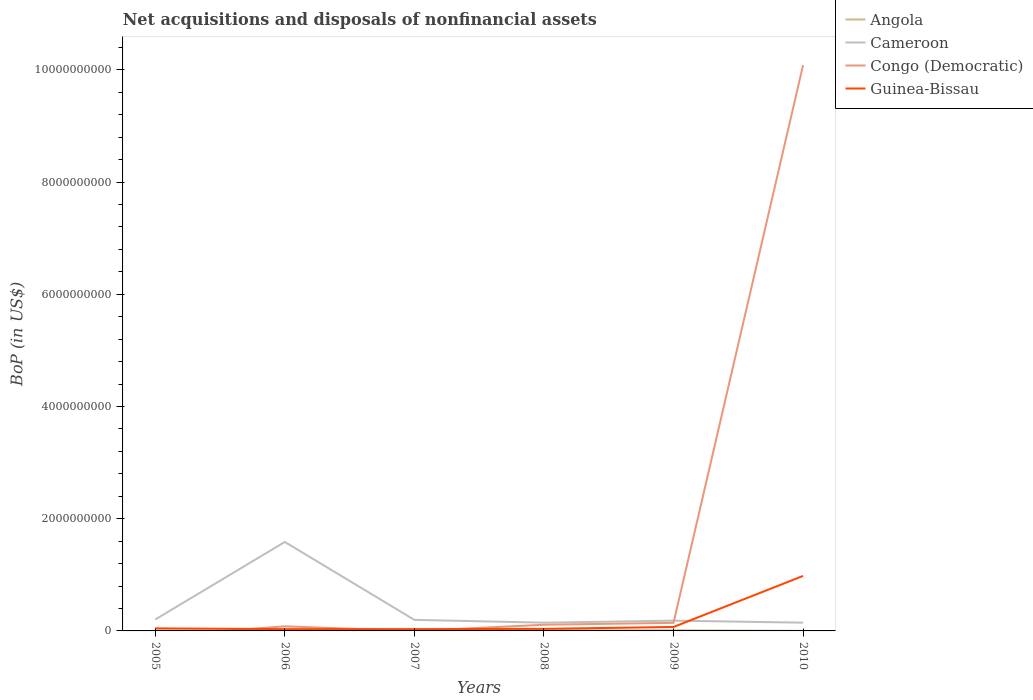How many different coloured lines are there?
Your response must be concise. 4. Does the line corresponding to Angola intersect with the line corresponding to Cameroon?
Offer a very short reply. No. Is the number of lines equal to the number of legend labels?
Your answer should be compact. No. Across all years, what is the maximum Balance of Payments in Guinea-Bissau?
Make the answer very short. 3.21e+07. What is the total Balance of Payments in Congo (Democratic) in the graph?
Offer a very short reply. -2.84e+07. What is the difference between the highest and the second highest Balance of Payments in Angola?
Your answer should be compact. 1.20e+07. What is the difference between the highest and the lowest Balance of Payments in Cameroon?
Make the answer very short. 1. How many lines are there?
Offer a terse response. 4. What is the difference between two consecutive major ticks on the Y-axis?
Offer a terse response. 2.00e+09. Are the values on the major ticks of Y-axis written in scientific E-notation?
Provide a short and direct response. No. Does the graph contain any zero values?
Your answer should be very brief. Yes. Does the graph contain grids?
Your answer should be compact. No. How are the legend labels stacked?
Ensure brevity in your answer.  Vertical. What is the title of the graph?
Keep it short and to the point. Net acquisitions and disposals of nonfinancial assets. What is the label or title of the Y-axis?
Make the answer very short. BoP (in US$). What is the BoP (in US$) of Angola in 2005?
Make the answer very short. 7.77e+06. What is the BoP (in US$) of Cameroon in 2005?
Provide a short and direct response. 2.04e+08. What is the BoP (in US$) in Congo (Democratic) in 2005?
Offer a terse response. 0. What is the BoP (in US$) in Guinea-Bissau in 2005?
Offer a very short reply. 4.54e+07. What is the BoP (in US$) of Angola in 2006?
Keep it short and to the point. 1.44e+06. What is the BoP (in US$) in Cameroon in 2006?
Offer a terse response. 1.59e+09. What is the BoP (in US$) of Congo (Democratic) in 2006?
Your response must be concise. 8.17e+07. What is the BoP (in US$) of Guinea-Bissau in 2006?
Provide a short and direct response. 3.22e+07. What is the BoP (in US$) of Angola in 2007?
Provide a succinct answer. 7.17e+06. What is the BoP (in US$) of Cameroon in 2007?
Your answer should be very brief. 1.97e+08. What is the BoP (in US$) of Congo (Democratic) in 2007?
Your answer should be compact. 0. What is the BoP (in US$) in Guinea-Bissau in 2007?
Your response must be concise. 3.21e+07. What is the BoP (in US$) in Angola in 2008?
Provide a succinct answer. 1.29e+07. What is the BoP (in US$) of Cameroon in 2008?
Provide a succinct answer. 1.47e+08. What is the BoP (in US$) in Congo (Democratic) in 2008?
Your answer should be compact. 1.10e+08. What is the BoP (in US$) in Guinea-Bissau in 2008?
Your answer should be compact. 3.68e+07. What is the BoP (in US$) of Angola in 2009?
Your response must be concise. 1.13e+07. What is the BoP (in US$) in Cameroon in 2009?
Give a very brief answer. 1.84e+08. What is the BoP (in US$) of Congo (Democratic) in 2009?
Offer a very short reply. 1.44e+08. What is the BoP (in US$) of Guinea-Bissau in 2009?
Your answer should be very brief. 7.05e+07. What is the BoP (in US$) in Angola in 2010?
Provide a succinct answer. 9.34e+05. What is the BoP (in US$) in Cameroon in 2010?
Keep it short and to the point. 1.47e+08. What is the BoP (in US$) in Congo (Democratic) in 2010?
Ensure brevity in your answer.  1.01e+1. What is the BoP (in US$) of Guinea-Bissau in 2010?
Make the answer very short. 9.80e+08. Across all years, what is the maximum BoP (in US$) in Angola?
Make the answer very short. 1.29e+07. Across all years, what is the maximum BoP (in US$) in Cameroon?
Provide a short and direct response. 1.59e+09. Across all years, what is the maximum BoP (in US$) in Congo (Democratic)?
Make the answer very short. 1.01e+1. Across all years, what is the maximum BoP (in US$) in Guinea-Bissau?
Offer a very short reply. 9.80e+08. Across all years, what is the minimum BoP (in US$) of Angola?
Keep it short and to the point. 9.34e+05. Across all years, what is the minimum BoP (in US$) of Cameroon?
Give a very brief answer. 1.47e+08. Across all years, what is the minimum BoP (in US$) in Guinea-Bissau?
Your answer should be very brief. 3.21e+07. What is the total BoP (in US$) of Angola in the graph?
Keep it short and to the point. 4.15e+07. What is the total BoP (in US$) in Cameroon in the graph?
Provide a short and direct response. 2.46e+09. What is the total BoP (in US$) of Congo (Democratic) in the graph?
Your response must be concise. 1.04e+1. What is the total BoP (in US$) of Guinea-Bissau in the graph?
Offer a very short reply. 1.20e+09. What is the difference between the BoP (in US$) in Angola in 2005 and that in 2006?
Provide a succinct answer. 6.33e+06. What is the difference between the BoP (in US$) of Cameroon in 2005 and that in 2006?
Keep it short and to the point. -1.38e+09. What is the difference between the BoP (in US$) in Guinea-Bissau in 2005 and that in 2006?
Give a very brief answer. 1.32e+07. What is the difference between the BoP (in US$) in Angola in 2005 and that in 2007?
Keep it short and to the point. 5.95e+05. What is the difference between the BoP (in US$) in Cameroon in 2005 and that in 2007?
Ensure brevity in your answer.  6.52e+06. What is the difference between the BoP (in US$) of Guinea-Bissau in 2005 and that in 2007?
Provide a succinct answer. 1.33e+07. What is the difference between the BoP (in US$) in Angola in 2005 and that in 2008?
Your answer should be very brief. -5.13e+06. What is the difference between the BoP (in US$) of Cameroon in 2005 and that in 2008?
Offer a very short reply. 5.68e+07. What is the difference between the BoP (in US$) in Guinea-Bissau in 2005 and that in 2008?
Offer a very short reply. 8.62e+06. What is the difference between the BoP (in US$) in Angola in 2005 and that in 2009?
Make the answer very short. -3.49e+06. What is the difference between the BoP (in US$) of Cameroon in 2005 and that in 2009?
Make the answer very short. 2.02e+07. What is the difference between the BoP (in US$) of Guinea-Bissau in 2005 and that in 2009?
Keep it short and to the point. -2.51e+07. What is the difference between the BoP (in US$) in Angola in 2005 and that in 2010?
Ensure brevity in your answer.  6.84e+06. What is the difference between the BoP (in US$) of Cameroon in 2005 and that in 2010?
Give a very brief answer. 5.67e+07. What is the difference between the BoP (in US$) in Guinea-Bissau in 2005 and that in 2010?
Your response must be concise. -9.35e+08. What is the difference between the BoP (in US$) of Angola in 2006 and that in 2007?
Offer a terse response. -5.73e+06. What is the difference between the BoP (in US$) of Cameroon in 2006 and that in 2007?
Make the answer very short. 1.39e+09. What is the difference between the BoP (in US$) in Guinea-Bissau in 2006 and that in 2007?
Make the answer very short. 7.78e+04. What is the difference between the BoP (in US$) in Angola in 2006 and that in 2008?
Your response must be concise. -1.15e+07. What is the difference between the BoP (in US$) of Cameroon in 2006 and that in 2008?
Ensure brevity in your answer.  1.44e+09. What is the difference between the BoP (in US$) of Congo (Democratic) in 2006 and that in 2008?
Ensure brevity in your answer.  -2.84e+07. What is the difference between the BoP (in US$) in Guinea-Bissau in 2006 and that in 2008?
Ensure brevity in your answer.  -4.58e+06. What is the difference between the BoP (in US$) of Angola in 2006 and that in 2009?
Give a very brief answer. -9.82e+06. What is the difference between the BoP (in US$) in Cameroon in 2006 and that in 2009?
Your answer should be compact. 1.40e+09. What is the difference between the BoP (in US$) in Congo (Democratic) in 2006 and that in 2009?
Your response must be concise. -6.22e+07. What is the difference between the BoP (in US$) in Guinea-Bissau in 2006 and that in 2009?
Your response must be concise. -3.83e+07. What is the difference between the BoP (in US$) in Angola in 2006 and that in 2010?
Your response must be concise. 5.06e+05. What is the difference between the BoP (in US$) of Cameroon in 2006 and that in 2010?
Provide a succinct answer. 1.44e+09. What is the difference between the BoP (in US$) of Congo (Democratic) in 2006 and that in 2010?
Offer a very short reply. -1.00e+1. What is the difference between the BoP (in US$) of Guinea-Bissau in 2006 and that in 2010?
Ensure brevity in your answer.  -9.48e+08. What is the difference between the BoP (in US$) of Angola in 2007 and that in 2008?
Provide a short and direct response. -5.72e+06. What is the difference between the BoP (in US$) of Cameroon in 2007 and that in 2008?
Your response must be concise. 5.03e+07. What is the difference between the BoP (in US$) in Guinea-Bissau in 2007 and that in 2008?
Give a very brief answer. -4.66e+06. What is the difference between the BoP (in US$) of Angola in 2007 and that in 2009?
Your answer should be compact. -4.08e+06. What is the difference between the BoP (in US$) in Cameroon in 2007 and that in 2009?
Keep it short and to the point. 1.36e+07. What is the difference between the BoP (in US$) in Guinea-Bissau in 2007 and that in 2009?
Offer a very short reply. -3.83e+07. What is the difference between the BoP (in US$) in Angola in 2007 and that in 2010?
Ensure brevity in your answer.  6.24e+06. What is the difference between the BoP (in US$) of Cameroon in 2007 and that in 2010?
Provide a succinct answer. 5.02e+07. What is the difference between the BoP (in US$) in Guinea-Bissau in 2007 and that in 2010?
Offer a terse response. -9.48e+08. What is the difference between the BoP (in US$) of Angola in 2008 and that in 2009?
Your answer should be compact. 1.64e+06. What is the difference between the BoP (in US$) in Cameroon in 2008 and that in 2009?
Ensure brevity in your answer.  -3.67e+07. What is the difference between the BoP (in US$) of Congo (Democratic) in 2008 and that in 2009?
Make the answer very short. -3.39e+07. What is the difference between the BoP (in US$) in Guinea-Bissau in 2008 and that in 2009?
Your response must be concise. -3.37e+07. What is the difference between the BoP (in US$) in Angola in 2008 and that in 2010?
Offer a very short reply. 1.20e+07. What is the difference between the BoP (in US$) in Cameroon in 2008 and that in 2010?
Ensure brevity in your answer.  -1.03e+05. What is the difference between the BoP (in US$) of Congo (Democratic) in 2008 and that in 2010?
Provide a short and direct response. -9.97e+09. What is the difference between the BoP (in US$) of Guinea-Bissau in 2008 and that in 2010?
Provide a short and direct response. -9.44e+08. What is the difference between the BoP (in US$) of Angola in 2009 and that in 2010?
Your answer should be very brief. 1.03e+07. What is the difference between the BoP (in US$) in Cameroon in 2009 and that in 2010?
Offer a very short reply. 3.65e+07. What is the difference between the BoP (in US$) in Congo (Democratic) in 2009 and that in 2010?
Offer a terse response. -9.94e+09. What is the difference between the BoP (in US$) in Guinea-Bissau in 2009 and that in 2010?
Make the answer very short. -9.10e+08. What is the difference between the BoP (in US$) of Angola in 2005 and the BoP (in US$) of Cameroon in 2006?
Your answer should be very brief. -1.58e+09. What is the difference between the BoP (in US$) of Angola in 2005 and the BoP (in US$) of Congo (Democratic) in 2006?
Your response must be concise. -7.40e+07. What is the difference between the BoP (in US$) of Angola in 2005 and the BoP (in US$) of Guinea-Bissau in 2006?
Ensure brevity in your answer.  -2.44e+07. What is the difference between the BoP (in US$) in Cameroon in 2005 and the BoP (in US$) in Congo (Democratic) in 2006?
Provide a short and direct response. 1.22e+08. What is the difference between the BoP (in US$) in Cameroon in 2005 and the BoP (in US$) in Guinea-Bissau in 2006?
Offer a very short reply. 1.71e+08. What is the difference between the BoP (in US$) in Angola in 2005 and the BoP (in US$) in Cameroon in 2007?
Provide a short and direct response. -1.89e+08. What is the difference between the BoP (in US$) in Angola in 2005 and the BoP (in US$) in Guinea-Bissau in 2007?
Keep it short and to the point. -2.44e+07. What is the difference between the BoP (in US$) in Cameroon in 2005 and the BoP (in US$) in Guinea-Bissau in 2007?
Keep it short and to the point. 1.72e+08. What is the difference between the BoP (in US$) of Angola in 2005 and the BoP (in US$) of Cameroon in 2008?
Give a very brief answer. -1.39e+08. What is the difference between the BoP (in US$) of Angola in 2005 and the BoP (in US$) of Congo (Democratic) in 2008?
Keep it short and to the point. -1.02e+08. What is the difference between the BoP (in US$) in Angola in 2005 and the BoP (in US$) in Guinea-Bissau in 2008?
Ensure brevity in your answer.  -2.90e+07. What is the difference between the BoP (in US$) of Cameroon in 2005 and the BoP (in US$) of Congo (Democratic) in 2008?
Your answer should be very brief. 9.36e+07. What is the difference between the BoP (in US$) of Cameroon in 2005 and the BoP (in US$) of Guinea-Bissau in 2008?
Provide a succinct answer. 1.67e+08. What is the difference between the BoP (in US$) of Angola in 2005 and the BoP (in US$) of Cameroon in 2009?
Your response must be concise. -1.76e+08. What is the difference between the BoP (in US$) of Angola in 2005 and the BoP (in US$) of Congo (Democratic) in 2009?
Give a very brief answer. -1.36e+08. What is the difference between the BoP (in US$) in Angola in 2005 and the BoP (in US$) in Guinea-Bissau in 2009?
Provide a succinct answer. -6.27e+07. What is the difference between the BoP (in US$) of Cameroon in 2005 and the BoP (in US$) of Congo (Democratic) in 2009?
Your answer should be compact. 5.97e+07. What is the difference between the BoP (in US$) of Cameroon in 2005 and the BoP (in US$) of Guinea-Bissau in 2009?
Offer a very short reply. 1.33e+08. What is the difference between the BoP (in US$) in Angola in 2005 and the BoP (in US$) in Cameroon in 2010?
Provide a short and direct response. -1.39e+08. What is the difference between the BoP (in US$) of Angola in 2005 and the BoP (in US$) of Congo (Democratic) in 2010?
Offer a terse response. -1.01e+1. What is the difference between the BoP (in US$) of Angola in 2005 and the BoP (in US$) of Guinea-Bissau in 2010?
Keep it short and to the point. -9.73e+08. What is the difference between the BoP (in US$) in Cameroon in 2005 and the BoP (in US$) in Congo (Democratic) in 2010?
Offer a very short reply. -9.88e+09. What is the difference between the BoP (in US$) in Cameroon in 2005 and the BoP (in US$) in Guinea-Bissau in 2010?
Offer a very short reply. -7.77e+08. What is the difference between the BoP (in US$) of Angola in 2006 and the BoP (in US$) of Cameroon in 2007?
Your answer should be very brief. -1.96e+08. What is the difference between the BoP (in US$) in Angola in 2006 and the BoP (in US$) in Guinea-Bissau in 2007?
Keep it short and to the point. -3.07e+07. What is the difference between the BoP (in US$) of Cameroon in 2006 and the BoP (in US$) of Guinea-Bissau in 2007?
Your answer should be very brief. 1.55e+09. What is the difference between the BoP (in US$) of Congo (Democratic) in 2006 and the BoP (in US$) of Guinea-Bissau in 2007?
Offer a very short reply. 4.96e+07. What is the difference between the BoP (in US$) in Angola in 2006 and the BoP (in US$) in Cameroon in 2008?
Make the answer very short. -1.45e+08. What is the difference between the BoP (in US$) in Angola in 2006 and the BoP (in US$) in Congo (Democratic) in 2008?
Make the answer very short. -1.09e+08. What is the difference between the BoP (in US$) of Angola in 2006 and the BoP (in US$) of Guinea-Bissau in 2008?
Provide a succinct answer. -3.53e+07. What is the difference between the BoP (in US$) in Cameroon in 2006 and the BoP (in US$) in Congo (Democratic) in 2008?
Provide a short and direct response. 1.48e+09. What is the difference between the BoP (in US$) of Cameroon in 2006 and the BoP (in US$) of Guinea-Bissau in 2008?
Offer a very short reply. 1.55e+09. What is the difference between the BoP (in US$) of Congo (Democratic) in 2006 and the BoP (in US$) of Guinea-Bissau in 2008?
Make the answer very short. 4.49e+07. What is the difference between the BoP (in US$) in Angola in 2006 and the BoP (in US$) in Cameroon in 2009?
Provide a short and direct response. -1.82e+08. What is the difference between the BoP (in US$) in Angola in 2006 and the BoP (in US$) in Congo (Democratic) in 2009?
Provide a short and direct response. -1.43e+08. What is the difference between the BoP (in US$) of Angola in 2006 and the BoP (in US$) of Guinea-Bissau in 2009?
Give a very brief answer. -6.90e+07. What is the difference between the BoP (in US$) in Cameroon in 2006 and the BoP (in US$) in Congo (Democratic) in 2009?
Offer a terse response. 1.44e+09. What is the difference between the BoP (in US$) in Cameroon in 2006 and the BoP (in US$) in Guinea-Bissau in 2009?
Your answer should be compact. 1.52e+09. What is the difference between the BoP (in US$) in Congo (Democratic) in 2006 and the BoP (in US$) in Guinea-Bissau in 2009?
Give a very brief answer. 1.13e+07. What is the difference between the BoP (in US$) in Angola in 2006 and the BoP (in US$) in Cameroon in 2010?
Offer a terse response. -1.46e+08. What is the difference between the BoP (in US$) in Angola in 2006 and the BoP (in US$) in Congo (Democratic) in 2010?
Offer a terse response. -1.01e+1. What is the difference between the BoP (in US$) in Angola in 2006 and the BoP (in US$) in Guinea-Bissau in 2010?
Give a very brief answer. -9.79e+08. What is the difference between the BoP (in US$) of Cameroon in 2006 and the BoP (in US$) of Congo (Democratic) in 2010?
Offer a very short reply. -8.50e+09. What is the difference between the BoP (in US$) in Cameroon in 2006 and the BoP (in US$) in Guinea-Bissau in 2010?
Your answer should be very brief. 6.05e+08. What is the difference between the BoP (in US$) in Congo (Democratic) in 2006 and the BoP (in US$) in Guinea-Bissau in 2010?
Make the answer very short. -8.99e+08. What is the difference between the BoP (in US$) in Angola in 2007 and the BoP (in US$) in Cameroon in 2008?
Make the answer very short. -1.40e+08. What is the difference between the BoP (in US$) of Angola in 2007 and the BoP (in US$) of Congo (Democratic) in 2008?
Your response must be concise. -1.03e+08. What is the difference between the BoP (in US$) of Angola in 2007 and the BoP (in US$) of Guinea-Bissau in 2008?
Keep it short and to the point. -2.96e+07. What is the difference between the BoP (in US$) of Cameroon in 2007 and the BoP (in US$) of Congo (Democratic) in 2008?
Your answer should be compact. 8.71e+07. What is the difference between the BoP (in US$) of Cameroon in 2007 and the BoP (in US$) of Guinea-Bissau in 2008?
Your response must be concise. 1.60e+08. What is the difference between the BoP (in US$) of Angola in 2007 and the BoP (in US$) of Cameroon in 2009?
Ensure brevity in your answer.  -1.76e+08. What is the difference between the BoP (in US$) in Angola in 2007 and the BoP (in US$) in Congo (Democratic) in 2009?
Provide a succinct answer. -1.37e+08. What is the difference between the BoP (in US$) in Angola in 2007 and the BoP (in US$) in Guinea-Bissau in 2009?
Offer a very short reply. -6.33e+07. What is the difference between the BoP (in US$) in Cameroon in 2007 and the BoP (in US$) in Congo (Democratic) in 2009?
Provide a succinct answer. 5.32e+07. What is the difference between the BoP (in US$) of Cameroon in 2007 and the BoP (in US$) of Guinea-Bissau in 2009?
Provide a short and direct response. 1.27e+08. What is the difference between the BoP (in US$) in Angola in 2007 and the BoP (in US$) in Cameroon in 2010?
Offer a terse response. -1.40e+08. What is the difference between the BoP (in US$) in Angola in 2007 and the BoP (in US$) in Congo (Democratic) in 2010?
Give a very brief answer. -1.01e+1. What is the difference between the BoP (in US$) in Angola in 2007 and the BoP (in US$) in Guinea-Bissau in 2010?
Offer a terse response. -9.73e+08. What is the difference between the BoP (in US$) of Cameroon in 2007 and the BoP (in US$) of Congo (Democratic) in 2010?
Your response must be concise. -9.89e+09. What is the difference between the BoP (in US$) in Cameroon in 2007 and the BoP (in US$) in Guinea-Bissau in 2010?
Your answer should be compact. -7.83e+08. What is the difference between the BoP (in US$) in Angola in 2008 and the BoP (in US$) in Cameroon in 2009?
Your response must be concise. -1.71e+08. What is the difference between the BoP (in US$) of Angola in 2008 and the BoP (in US$) of Congo (Democratic) in 2009?
Ensure brevity in your answer.  -1.31e+08. What is the difference between the BoP (in US$) in Angola in 2008 and the BoP (in US$) in Guinea-Bissau in 2009?
Your answer should be very brief. -5.76e+07. What is the difference between the BoP (in US$) of Cameroon in 2008 and the BoP (in US$) of Congo (Democratic) in 2009?
Provide a succinct answer. 2.90e+06. What is the difference between the BoP (in US$) in Cameroon in 2008 and the BoP (in US$) in Guinea-Bissau in 2009?
Provide a short and direct response. 7.64e+07. What is the difference between the BoP (in US$) in Congo (Democratic) in 2008 and the BoP (in US$) in Guinea-Bissau in 2009?
Make the answer very short. 3.96e+07. What is the difference between the BoP (in US$) of Angola in 2008 and the BoP (in US$) of Cameroon in 2010?
Your answer should be compact. -1.34e+08. What is the difference between the BoP (in US$) of Angola in 2008 and the BoP (in US$) of Congo (Democratic) in 2010?
Offer a very short reply. -1.01e+1. What is the difference between the BoP (in US$) in Angola in 2008 and the BoP (in US$) in Guinea-Bissau in 2010?
Provide a succinct answer. -9.68e+08. What is the difference between the BoP (in US$) of Cameroon in 2008 and the BoP (in US$) of Congo (Democratic) in 2010?
Your answer should be compact. -9.94e+09. What is the difference between the BoP (in US$) of Cameroon in 2008 and the BoP (in US$) of Guinea-Bissau in 2010?
Provide a short and direct response. -8.34e+08. What is the difference between the BoP (in US$) of Congo (Democratic) in 2008 and the BoP (in US$) of Guinea-Bissau in 2010?
Provide a succinct answer. -8.70e+08. What is the difference between the BoP (in US$) in Angola in 2009 and the BoP (in US$) in Cameroon in 2010?
Make the answer very short. -1.36e+08. What is the difference between the BoP (in US$) of Angola in 2009 and the BoP (in US$) of Congo (Democratic) in 2010?
Your answer should be compact. -1.01e+1. What is the difference between the BoP (in US$) in Angola in 2009 and the BoP (in US$) in Guinea-Bissau in 2010?
Make the answer very short. -9.69e+08. What is the difference between the BoP (in US$) in Cameroon in 2009 and the BoP (in US$) in Congo (Democratic) in 2010?
Offer a very short reply. -9.90e+09. What is the difference between the BoP (in US$) in Cameroon in 2009 and the BoP (in US$) in Guinea-Bissau in 2010?
Make the answer very short. -7.97e+08. What is the difference between the BoP (in US$) of Congo (Democratic) in 2009 and the BoP (in US$) of Guinea-Bissau in 2010?
Ensure brevity in your answer.  -8.36e+08. What is the average BoP (in US$) of Angola per year?
Your answer should be compact. 6.91e+06. What is the average BoP (in US$) in Cameroon per year?
Your answer should be compact. 4.11e+08. What is the average BoP (in US$) in Congo (Democratic) per year?
Offer a terse response. 1.74e+09. What is the average BoP (in US$) in Guinea-Bissau per year?
Provide a succinct answer. 2.00e+08. In the year 2005, what is the difference between the BoP (in US$) in Angola and BoP (in US$) in Cameroon?
Offer a terse response. -1.96e+08. In the year 2005, what is the difference between the BoP (in US$) in Angola and BoP (in US$) in Guinea-Bissau?
Provide a succinct answer. -3.76e+07. In the year 2005, what is the difference between the BoP (in US$) of Cameroon and BoP (in US$) of Guinea-Bissau?
Ensure brevity in your answer.  1.58e+08. In the year 2006, what is the difference between the BoP (in US$) of Angola and BoP (in US$) of Cameroon?
Provide a succinct answer. -1.58e+09. In the year 2006, what is the difference between the BoP (in US$) of Angola and BoP (in US$) of Congo (Democratic)?
Ensure brevity in your answer.  -8.03e+07. In the year 2006, what is the difference between the BoP (in US$) of Angola and BoP (in US$) of Guinea-Bissau?
Make the answer very short. -3.08e+07. In the year 2006, what is the difference between the BoP (in US$) of Cameroon and BoP (in US$) of Congo (Democratic)?
Your response must be concise. 1.50e+09. In the year 2006, what is the difference between the BoP (in US$) in Cameroon and BoP (in US$) in Guinea-Bissau?
Your answer should be very brief. 1.55e+09. In the year 2006, what is the difference between the BoP (in US$) in Congo (Democratic) and BoP (in US$) in Guinea-Bissau?
Offer a very short reply. 4.95e+07. In the year 2007, what is the difference between the BoP (in US$) in Angola and BoP (in US$) in Cameroon?
Offer a terse response. -1.90e+08. In the year 2007, what is the difference between the BoP (in US$) of Angola and BoP (in US$) of Guinea-Bissau?
Your answer should be compact. -2.49e+07. In the year 2007, what is the difference between the BoP (in US$) in Cameroon and BoP (in US$) in Guinea-Bissau?
Keep it short and to the point. 1.65e+08. In the year 2008, what is the difference between the BoP (in US$) in Angola and BoP (in US$) in Cameroon?
Offer a terse response. -1.34e+08. In the year 2008, what is the difference between the BoP (in US$) of Angola and BoP (in US$) of Congo (Democratic)?
Offer a terse response. -9.72e+07. In the year 2008, what is the difference between the BoP (in US$) in Angola and BoP (in US$) in Guinea-Bissau?
Offer a terse response. -2.39e+07. In the year 2008, what is the difference between the BoP (in US$) in Cameroon and BoP (in US$) in Congo (Democratic)?
Your answer should be very brief. 3.68e+07. In the year 2008, what is the difference between the BoP (in US$) of Cameroon and BoP (in US$) of Guinea-Bissau?
Offer a very short reply. 1.10e+08. In the year 2008, what is the difference between the BoP (in US$) of Congo (Democratic) and BoP (in US$) of Guinea-Bissau?
Give a very brief answer. 7.33e+07. In the year 2009, what is the difference between the BoP (in US$) of Angola and BoP (in US$) of Cameroon?
Your answer should be compact. -1.72e+08. In the year 2009, what is the difference between the BoP (in US$) in Angola and BoP (in US$) in Congo (Democratic)?
Provide a short and direct response. -1.33e+08. In the year 2009, what is the difference between the BoP (in US$) of Angola and BoP (in US$) of Guinea-Bissau?
Make the answer very short. -5.92e+07. In the year 2009, what is the difference between the BoP (in US$) of Cameroon and BoP (in US$) of Congo (Democratic)?
Offer a terse response. 3.96e+07. In the year 2009, what is the difference between the BoP (in US$) of Cameroon and BoP (in US$) of Guinea-Bissau?
Offer a very short reply. 1.13e+08. In the year 2009, what is the difference between the BoP (in US$) in Congo (Democratic) and BoP (in US$) in Guinea-Bissau?
Give a very brief answer. 7.35e+07. In the year 2010, what is the difference between the BoP (in US$) in Angola and BoP (in US$) in Cameroon?
Offer a very short reply. -1.46e+08. In the year 2010, what is the difference between the BoP (in US$) of Angola and BoP (in US$) of Congo (Democratic)?
Provide a succinct answer. -1.01e+1. In the year 2010, what is the difference between the BoP (in US$) of Angola and BoP (in US$) of Guinea-Bissau?
Your answer should be very brief. -9.79e+08. In the year 2010, what is the difference between the BoP (in US$) in Cameroon and BoP (in US$) in Congo (Democratic)?
Make the answer very short. -9.94e+09. In the year 2010, what is the difference between the BoP (in US$) in Cameroon and BoP (in US$) in Guinea-Bissau?
Make the answer very short. -8.33e+08. In the year 2010, what is the difference between the BoP (in US$) in Congo (Democratic) and BoP (in US$) in Guinea-Bissau?
Give a very brief answer. 9.10e+09. What is the ratio of the BoP (in US$) in Angola in 2005 to that in 2006?
Offer a terse response. 5.4. What is the ratio of the BoP (in US$) of Cameroon in 2005 to that in 2006?
Give a very brief answer. 0.13. What is the ratio of the BoP (in US$) in Guinea-Bissau in 2005 to that in 2006?
Your response must be concise. 1.41. What is the ratio of the BoP (in US$) of Angola in 2005 to that in 2007?
Ensure brevity in your answer.  1.08. What is the ratio of the BoP (in US$) of Cameroon in 2005 to that in 2007?
Your answer should be compact. 1.03. What is the ratio of the BoP (in US$) in Guinea-Bissau in 2005 to that in 2007?
Make the answer very short. 1.41. What is the ratio of the BoP (in US$) of Angola in 2005 to that in 2008?
Offer a very short reply. 0.6. What is the ratio of the BoP (in US$) of Cameroon in 2005 to that in 2008?
Provide a succinct answer. 1.39. What is the ratio of the BoP (in US$) of Guinea-Bissau in 2005 to that in 2008?
Make the answer very short. 1.23. What is the ratio of the BoP (in US$) in Angola in 2005 to that in 2009?
Provide a succinct answer. 0.69. What is the ratio of the BoP (in US$) of Cameroon in 2005 to that in 2009?
Make the answer very short. 1.11. What is the ratio of the BoP (in US$) in Guinea-Bissau in 2005 to that in 2009?
Your response must be concise. 0.64. What is the ratio of the BoP (in US$) of Angola in 2005 to that in 2010?
Provide a short and direct response. 8.32. What is the ratio of the BoP (in US$) of Cameroon in 2005 to that in 2010?
Your response must be concise. 1.39. What is the ratio of the BoP (in US$) in Guinea-Bissau in 2005 to that in 2010?
Offer a terse response. 0.05. What is the ratio of the BoP (in US$) of Angola in 2006 to that in 2007?
Your answer should be compact. 0.2. What is the ratio of the BoP (in US$) in Cameroon in 2006 to that in 2007?
Keep it short and to the point. 8.04. What is the ratio of the BoP (in US$) in Guinea-Bissau in 2006 to that in 2007?
Offer a very short reply. 1. What is the ratio of the BoP (in US$) in Angola in 2006 to that in 2008?
Your answer should be very brief. 0.11. What is the ratio of the BoP (in US$) of Cameroon in 2006 to that in 2008?
Provide a short and direct response. 10.79. What is the ratio of the BoP (in US$) of Congo (Democratic) in 2006 to that in 2008?
Offer a terse response. 0.74. What is the ratio of the BoP (in US$) of Guinea-Bissau in 2006 to that in 2008?
Your answer should be compact. 0.88. What is the ratio of the BoP (in US$) in Angola in 2006 to that in 2009?
Your response must be concise. 0.13. What is the ratio of the BoP (in US$) in Cameroon in 2006 to that in 2009?
Give a very brief answer. 8.64. What is the ratio of the BoP (in US$) of Congo (Democratic) in 2006 to that in 2009?
Keep it short and to the point. 0.57. What is the ratio of the BoP (in US$) of Guinea-Bissau in 2006 to that in 2009?
Your response must be concise. 0.46. What is the ratio of the BoP (in US$) in Angola in 2006 to that in 2010?
Provide a short and direct response. 1.54. What is the ratio of the BoP (in US$) of Cameroon in 2006 to that in 2010?
Make the answer very short. 10.79. What is the ratio of the BoP (in US$) in Congo (Democratic) in 2006 to that in 2010?
Make the answer very short. 0.01. What is the ratio of the BoP (in US$) of Guinea-Bissau in 2006 to that in 2010?
Provide a short and direct response. 0.03. What is the ratio of the BoP (in US$) of Angola in 2007 to that in 2008?
Offer a very short reply. 0.56. What is the ratio of the BoP (in US$) of Cameroon in 2007 to that in 2008?
Your answer should be very brief. 1.34. What is the ratio of the BoP (in US$) in Guinea-Bissau in 2007 to that in 2008?
Provide a succinct answer. 0.87. What is the ratio of the BoP (in US$) in Angola in 2007 to that in 2009?
Give a very brief answer. 0.64. What is the ratio of the BoP (in US$) of Cameroon in 2007 to that in 2009?
Your response must be concise. 1.07. What is the ratio of the BoP (in US$) of Guinea-Bissau in 2007 to that in 2009?
Give a very brief answer. 0.46. What is the ratio of the BoP (in US$) in Angola in 2007 to that in 2010?
Your answer should be compact. 7.68. What is the ratio of the BoP (in US$) in Cameroon in 2007 to that in 2010?
Keep it short and to the point. 1.34. What is the ratio of the BoP (in US$) of Guinea-Bissau in 2007 to that in 2010?
Your answer should be very brief. 0.03. What is the ratio of the BoP (in US$) of Angola in 2008 to that in 2009?
Your response must be concise. 1.15. What is the ratio of the BoP (in US$) in Cameroon in 2008 to that in 2009?
Make the answer very short. 0.8. What is the ratio of the BoP (in US$) in Congo (Democratic) in 2008 to that in 2009?
Make the answer very short. 0.76. What is the ratio of the BoP (in US$) in Guinea-Bissau in 2008 to that in 2009?
Provide a short and direct response. 0.52. What is the ratio of the BoP (in US$) of Angola in 2008 to that in 2010?
Your answer should be very brief. 13.81. What is the ratio of the BoP (in US$) of Cameroon in 2008 to that in 2010?
Offer a very short reply. 1. What is the ratio of the BoP (in US$) in Congo (Democratic) in 2008 to that in 2010?
Ensure brevity in your answer.  0.01. What is the ratio of the BoP (in US$) in Guinea-Bissau in 2008 to that in 2010?
Keep it short and to the point. 0.04. What is the ratio of the BoP (in US$) of Angola in 2009 to that in 2010?
Offer a very short reply. 12.05. What is the ratio of the BoP (in US$) of Cameroon in 2009 to that in 2010?
Make the answer very short. 1.25. What is the ratio of the BoP (in US$) in Congo (Democratic) in 2009 to that in 2010?
Ensure brevity in your answer.  0.01. What is the ratio of the BoP (in US$) of Guinea-Bissau in 2009 to that in 2010?
Offer a terse response. 0.07. What is the difference between the highest and the second highest BoP (in US$) in Angola?
Your answer should be compact. 1.64e+06. What is the difference between the highest and the second highest BoP (in US$) of Cameroon?
Make the answer very short. 1.38e+09. What is the difference between the highest and the second highest BoP (in US$) of Congo (Democratic)?
Ensure brevity in your answer.  9.94e+09. What is the difference between the highest and the second highest BoP (in US$) of Guinea-Bissau?
Make the answer very short. 9.10e+08. What is the difference between the highest and the lowest BoP (in US$) of Angola?
Offer a terse response. 1.20e+07. What is the difference between the highest and the lowest BoP (in US$) of Cameroon?
Your answer should be compact. 1.44e+09. What is the difference between the highest and the lowest BoP (in US$) of Congo (Democratic)?
Your answer should be compact. 1.01e+1. What is the difference between the highest and the lowest BoP (in US$) in Guinea-Bissau?
Provide a succinct answer. 9.48e+08. 